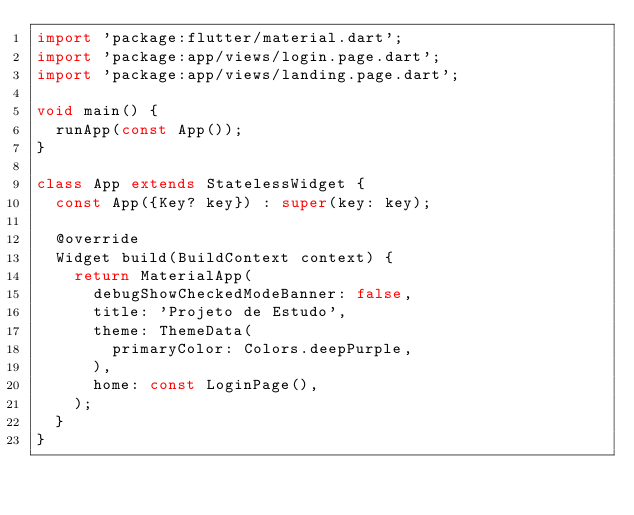<code> <loc_0><loc_0><loc_500><loc_500><_Dart_>import 'package:flutter/material.dart';
import 'package:app/views/login.page.dart';
import 'package:app/views/landing.page.dart';

void main() {
  runApp(const App());
}

class App extends StatelessWidget {
  const App({Key? key}) : super(key: key);

  @override
  Widget build(BuildContext context) {
    return MaterialApp(
      debugShowCheckedModeBanner: false,
      title: 'Projeto de Estudo',
      theme: ThemeData(
        primaryColor: Colors.deepPurple,
      ),
      home: const LoginPage(),
    );
  }
}
</code> 